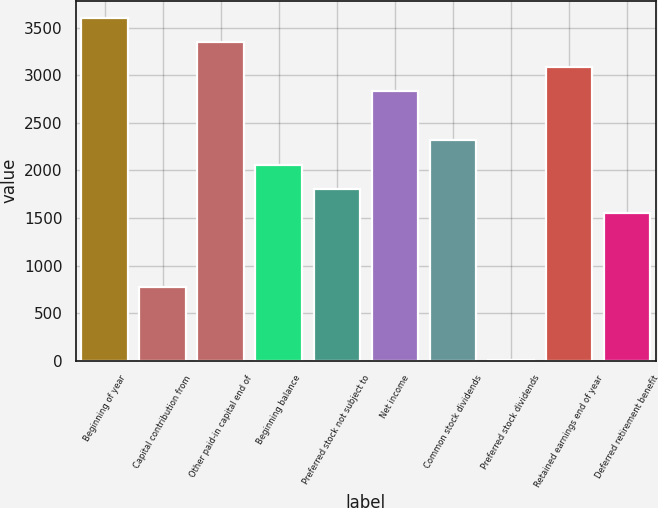<chart> <loc_0><loc_0><loc_500><loc_500><bar_chart><fcel>Beginning of year<fcel>Capital contribution from<fcel>Other paid-in capital end of<fcel>Beginning balance<fcel>Preferred stock not subject to<fcel>Net income<fcel>Common stock dividends<fcel>Preferred stock dividends<fcel>Retained earnings end of year<fcel>Deferred retirement benefit<nl><fcel>3604.8<fcel>775.6<fcel>3347.6<fcel>2061.6<fcel>1804.4<fcel>2833.2<fcel>2318.8<fcel>4<fcel>3090.4<fcel>1547.2<nl></chart> 